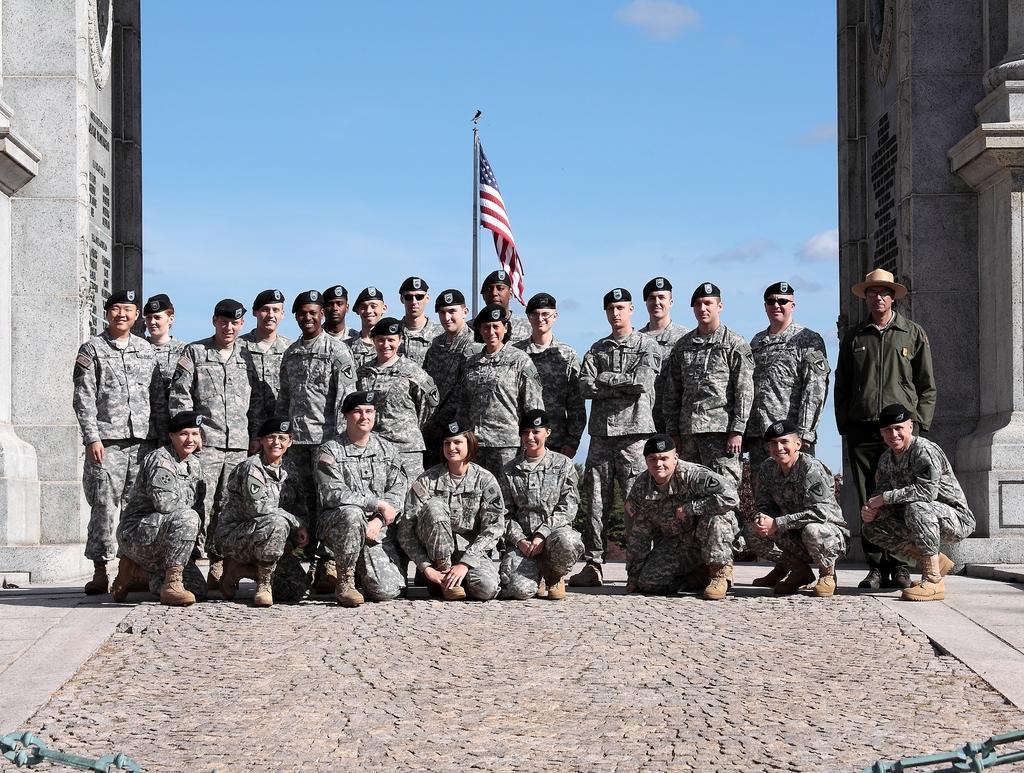Describe this image in one or two sentences. In this image we can see people. They are wearing caps. One person is wearing hat. In the back there is a flag with pole. On the sides there are walls. In the background there is sky with clouds. 